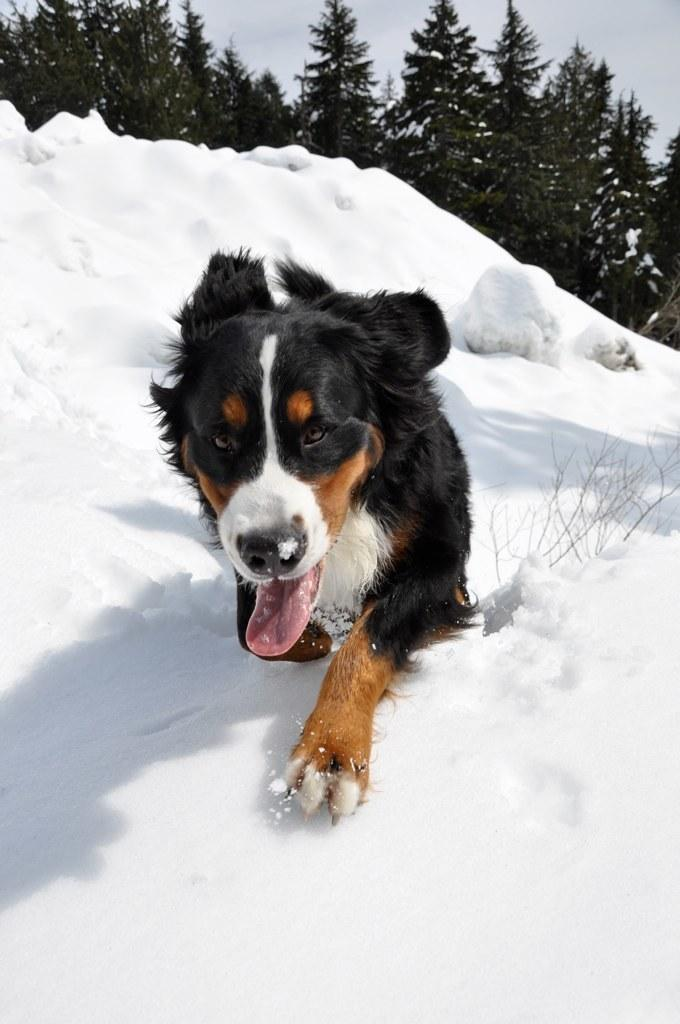What animal can be seen in the image? There is a dog in the image. What is the environment like around the dog? There is a lot of ice around the dog. What can be seen in the distance in the image? There are trees visible in the background of the image. Where is the crowd gathered for recess in the image? There is no crowd or recess present in the image; it features a dog surrounded by ice with trees in the background. 